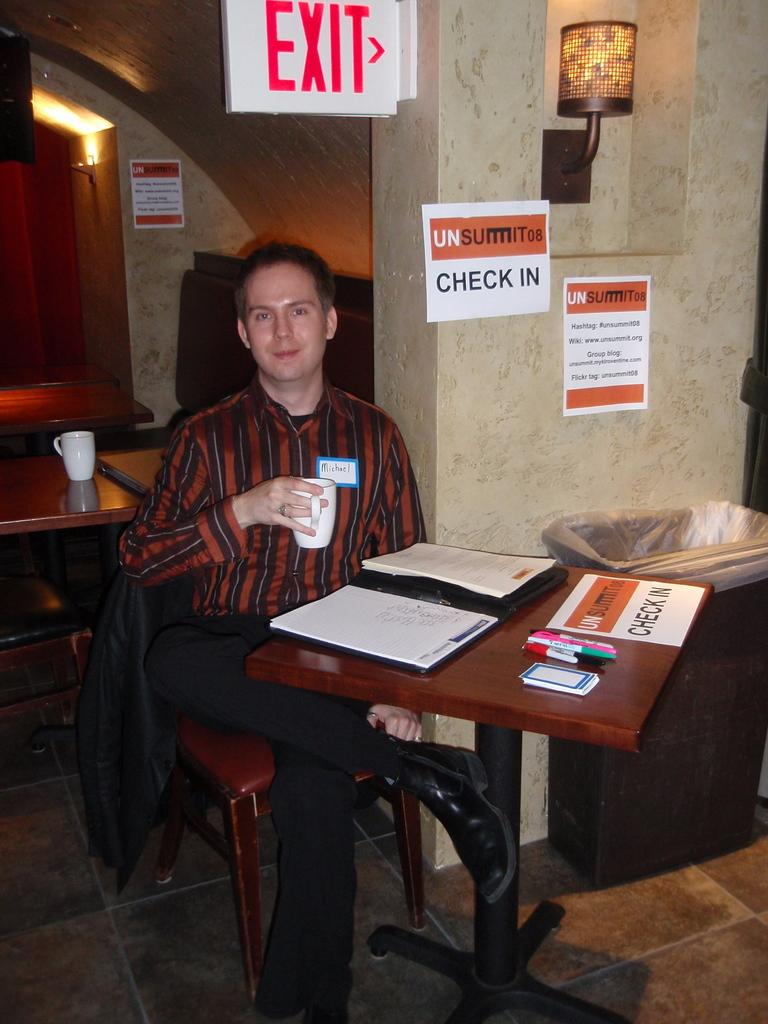What is the man in the image doing? The man is sitting in a chair. Where is the chair located in relation to the table? The chair is near a table. What items can be seen on the table? There is a book, a pen, a card, and a cup on the table. What can be seen in the background of the image? There is a wall, a lamp, a door, and a dustbin in the background. How much money does the man have in his hand in the image? There is no indication of money in the image; the man is not holding any money. 